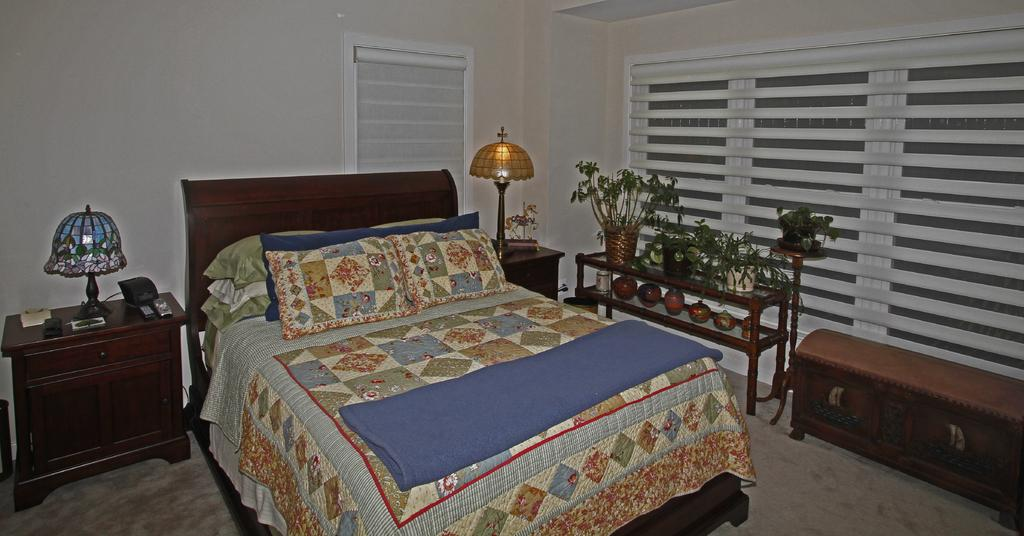What type of room is shown in the image? The image depicts a bedroom. What furniture is present in the bedroom? There are beds and a table in the bedroom. What objects are on the table in the bedroom? Lamps are present on the table. Are there any plants in the bedroom that need to be watered? There is no information about plants in the bedroom, so we cannot determine if any need to be watered. Is there a payment system for using the beds in the bedroom? There is no mention of a payment system in the image or the provided facts. 